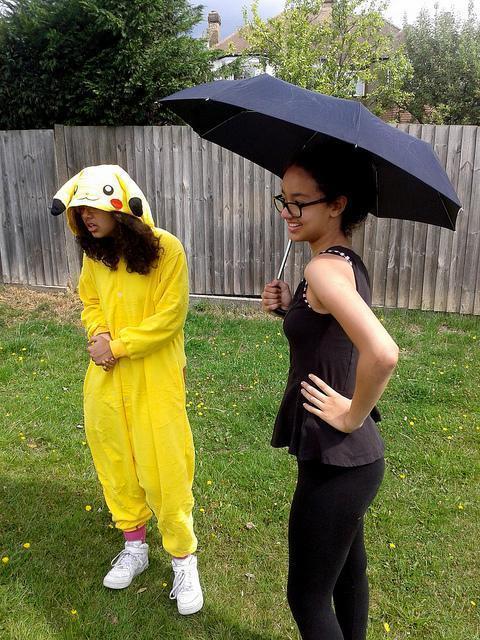What do the girls use the umbrella to avoid in this situation?
Make your selection and explain in format: 'Answer: answer
Rationale: rationale.'
Options: Sunburn, getting soaked, lightning, hail. Answer: sunburn.
Rationale: The women don't want to get burned from the sun. 